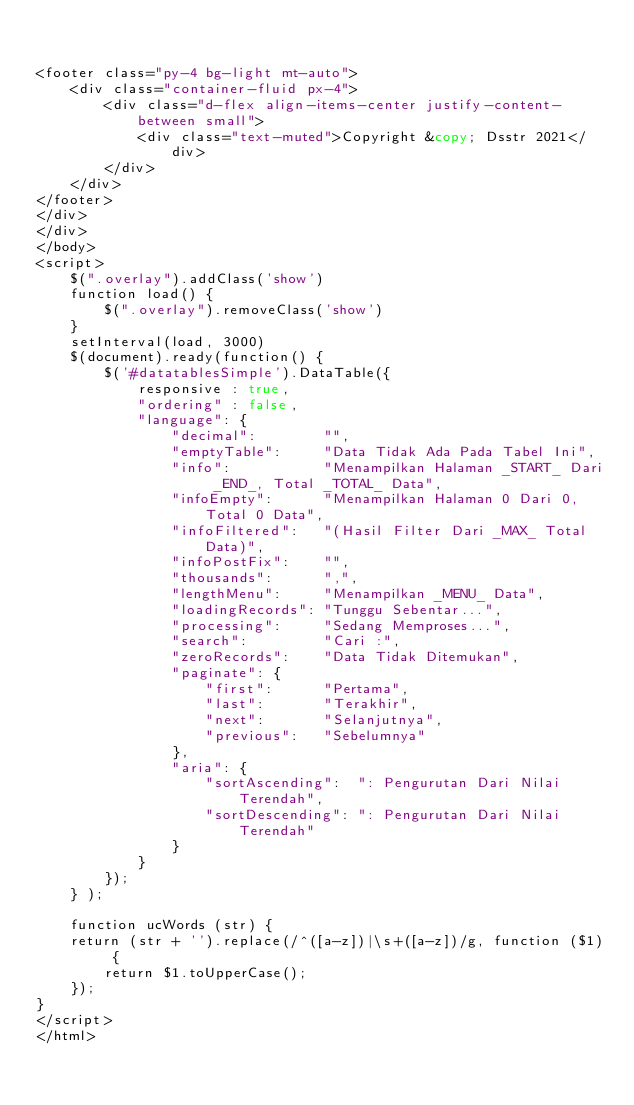<code> <loc_0><loc_0><loc_500><loc_500><_PHP_>

<footer class="py-4 bg-light mt-auto">
    <div class="container-fluid px-4">
        <div class="d-flex align-items-center justify-content-between small">
            <div class="text-muted">Copyright &copy; Dsstr 2021</div>
        </div>
    </div>
</footer>
</div>
</div>
</body>
<script>
    $(".overlay").addClass('show')
    function load() {
        $(".overlay").removeClass('show')
    }
    setInterval(load, 3000)
    $(document).ready(function() {
        $('#datatablesSimple').DataTable({
            responsive : true,
            "ordering" : false,
            "language": {
                "decimal":        "",
                "emptyTable":     "Data Tidak Ada Pada Tabel Ini",
                "info":           "Menampilkan Halaman _START_ Dari _END_, Total _TOTAL_ Data",
                "infoEmpty":      "Menampilkan Halaman 0 Dari 0, Total 0 Data",
                "infoFiltered":   "(Hasil Filter Dari _MAX_ Total Data)",
                "infoPostFix":    "",
                "thousands":      ",",
                "lengthMenu":     "Menampilkan _MENU_ Data",
                "loadingRecords": "Tunggu Sebentar...",
                "processing":     "Sedang Memproses...",
                "search":         "Cari :",
                "zeroRecords":    "Data Tidak Ditemukan",
                "paginate": {
                    "first":      "Pertama",
                    "last":       "Terakhir",
                    "next":       "Selanjutnya",
                    "previous":   "Sebelumnya"
                },
                "aria": {
                    "sortAscending":  ": Pengurutan Dari Nilai Terendah",
                    "sortDescending": ": Pengurutan Dari Nilai Terendah"
                }
            }
        });
    } );

    function ucWords (str) {
    return (str + '').replace(/^([a-z])|\s+([a-z])/g, function ($1) {
        return $1.toUpperCase();
    });
}
</script>
</html>
</code> 